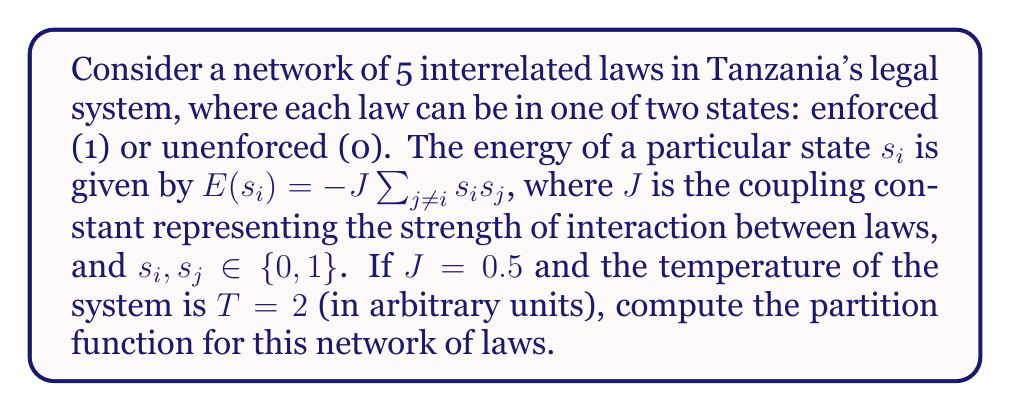Could you help me with this problem? To solve this problem, we'll follow these steps:

1) The partition function is given by:

   $$Z = \sum_{\text{all states}} e^{-\beta E(s)}$$

   where $\beta = \frac{1}{k_B T}$, and $k_B$ is Boltzmann's constant (which we'll assume to be 1 in our arbitrary units).

2) In this case, $\beta = \frac{1}{2}$.

3) For 5 laws, we have $2^5 = 32$ possible states.

4) The energy for each state is:

   $$E(s) = -0.5 \sum_{i < j} s_i s_j$$

5) We need to calculate this energy for each of the 32 states and sum up $e^{-\beta E(s)}$.

6) Let's consider a few examples:
   - For state (00000), $E = 0$, so contribution to Z is $e^0 = 1$
   - For state (10000), $E = 0$, so contribution to Z is also 1
   - For state (11000), $E = -0.5$, so contribution is $e^{0.25} \approx 1.2840$
   - For state (11111), $E = -5$, so contribution is $e^{2.5} \approx 12.1825$

7) Calculating this for all 32 states and summing:

   $$Z = 2 + 10 \cdot e^{0.25} + 10 \cdot e^{0.5} + 5 \cdot e^{1} + 5 \cdot e^{1.5} + e^{2.5}$$

8) Evaluating this expression:

   $$Z \approx 2 + 12.8402 + 16.4872 + 13.5914 + 22.4564 + 12.1825$$

9) Finally:

   $$Z \approx 79.5577$$
Answer: $Z \approx 79.5577$ 